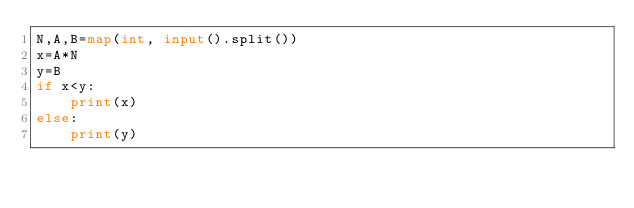<code> <loc_0><loc_0><loc_500><loc_500><_Python_>N,A,B=map(int, input().split())
x=A*N
y=B
if x<y:
    print(x)
else:
    print(y)</code> 